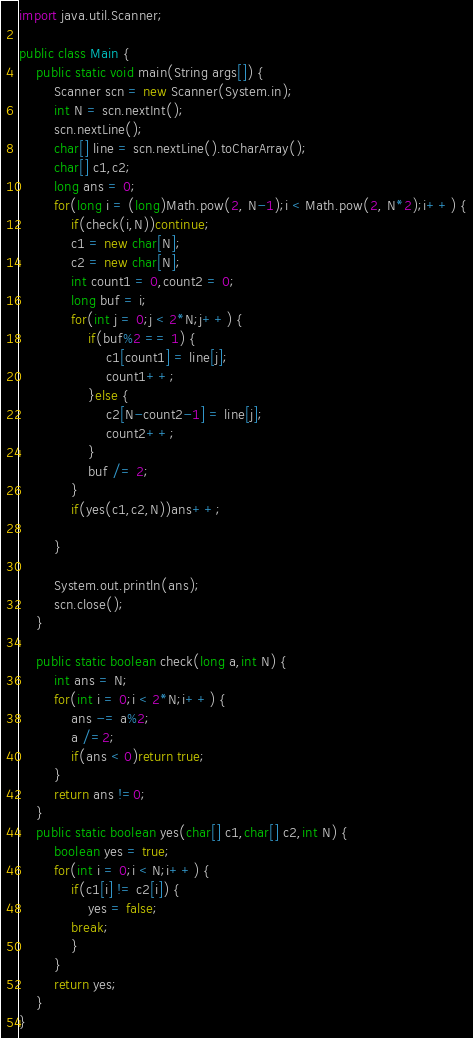<code> <loc_0><loc_0><loc_500><loc_500><_Java_>import java.util.Scanner;

public class Main {
	public static void main(String args[]) {
		Scanner scn = new Scanner(System.in);
		int N = scn.nextInt();
		scn.nextLine();
		char[] line = scn.nextLine().toCharArray();
		char[] c1,c2;
		long ans = 0;
		for(long i = (long)Math.pow(2, N-1);i < Math.pow(2, N*2);i++) {
			if(check(i,N))continue;
			c1 = new char[N];
			c2 = new char[N];
			int count1 = 0,count2 = 0;
			long buf = i;
			for(int j = 0;j < 2*N;j++) {
				if(buf%2 == 1) {
					c1[count1] = line[j];
					count1++;
				}else {
					c2[N-count2-1] = line[j];
					count2++;
				}
				buf /= 2;
			}
			if(yes(c1,c2,N))ans++;

		}

		System.out.println(ans);
		scn.close();
	}

	public static boolean check(long a,int N) {
		int ans = N;
		for(int i = 0;i < 2*N;i++) {
			ans -= a%2;
			a /=2;
			if(ans < 0)return true;
		}
		return ans !=0;
	}
	public static boolean yes(char[] c1,char[] c2,int N) {
		boolean yes = true;
		for(int i = 0;i < N;i++) {
			if(c1[i] != c2[i]) {
				yes = false;
			break;
			}
		}
		return yes;
	}
}
</code> 